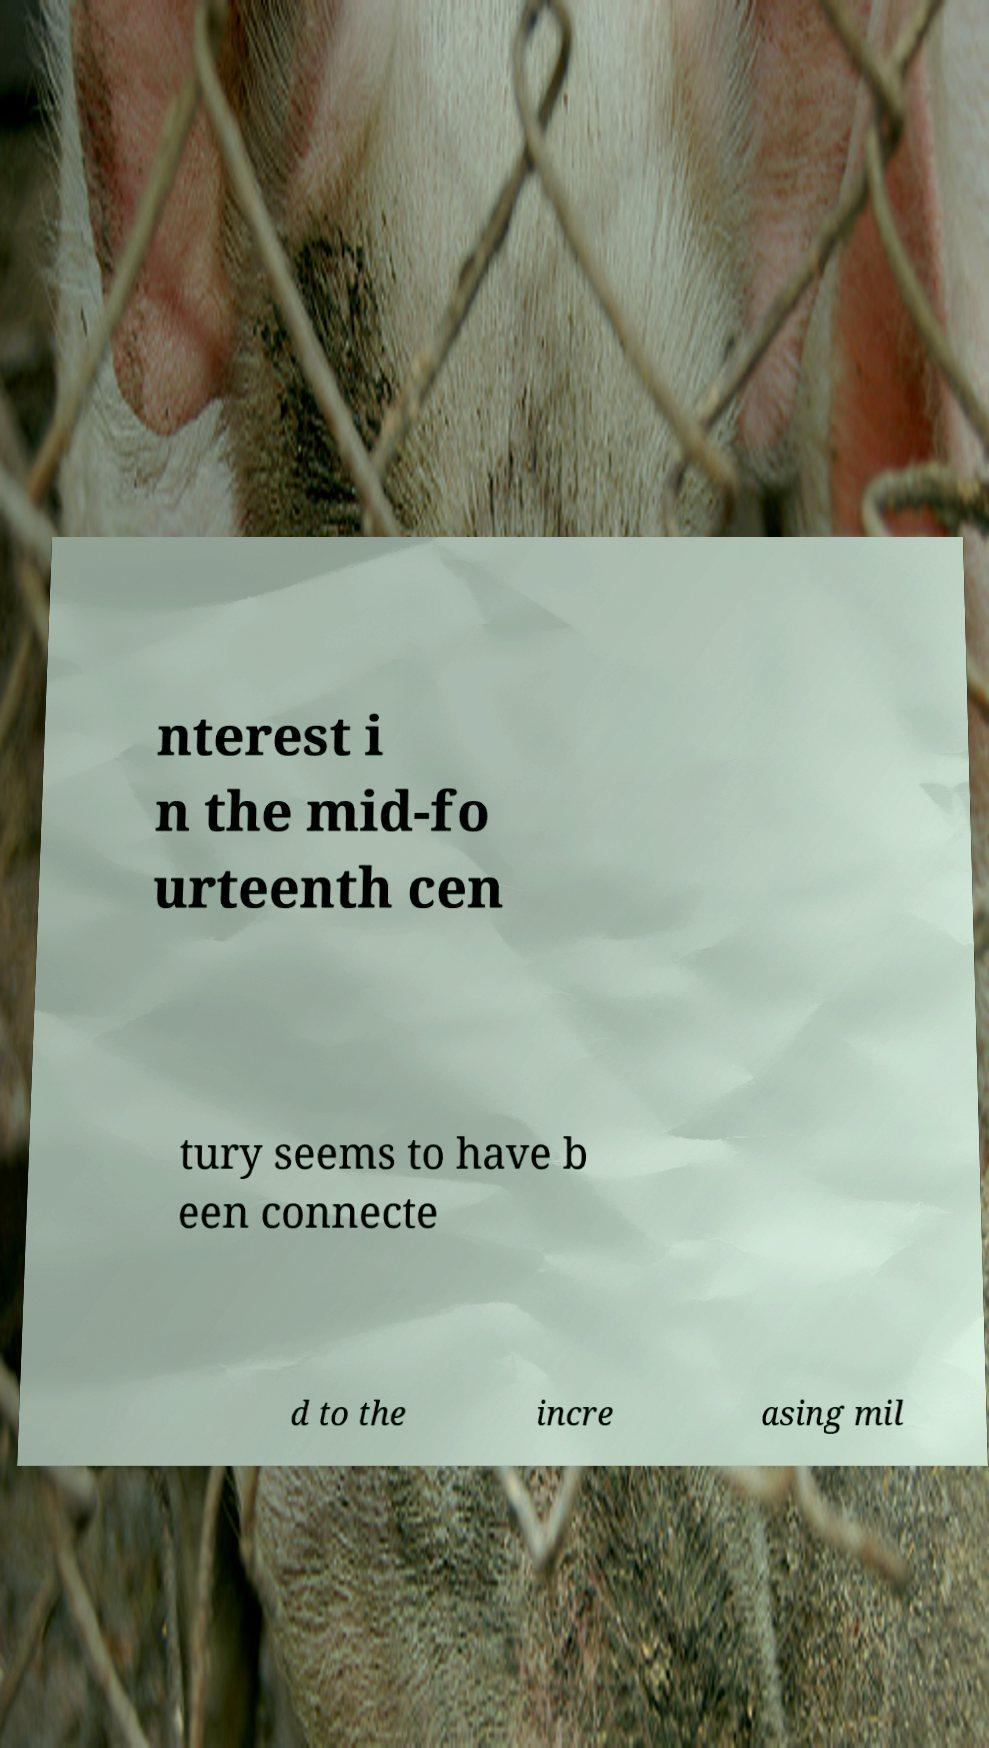Please identify and transcribe the text found in this image. nterest i n the mid-fo urteenth cen tury seems to have b een connecte d to the incre asing mil 